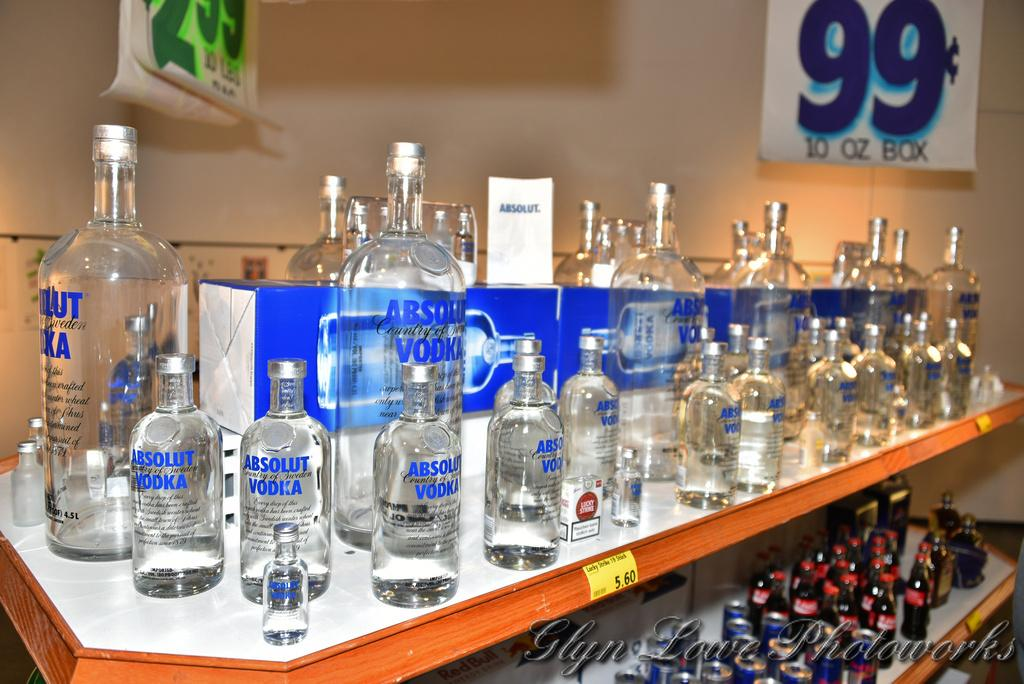Provide a one-sentence caption for the provided image. A bunch of Vodka bottles sit on the shelf with a large 99 cents sign in the back. 